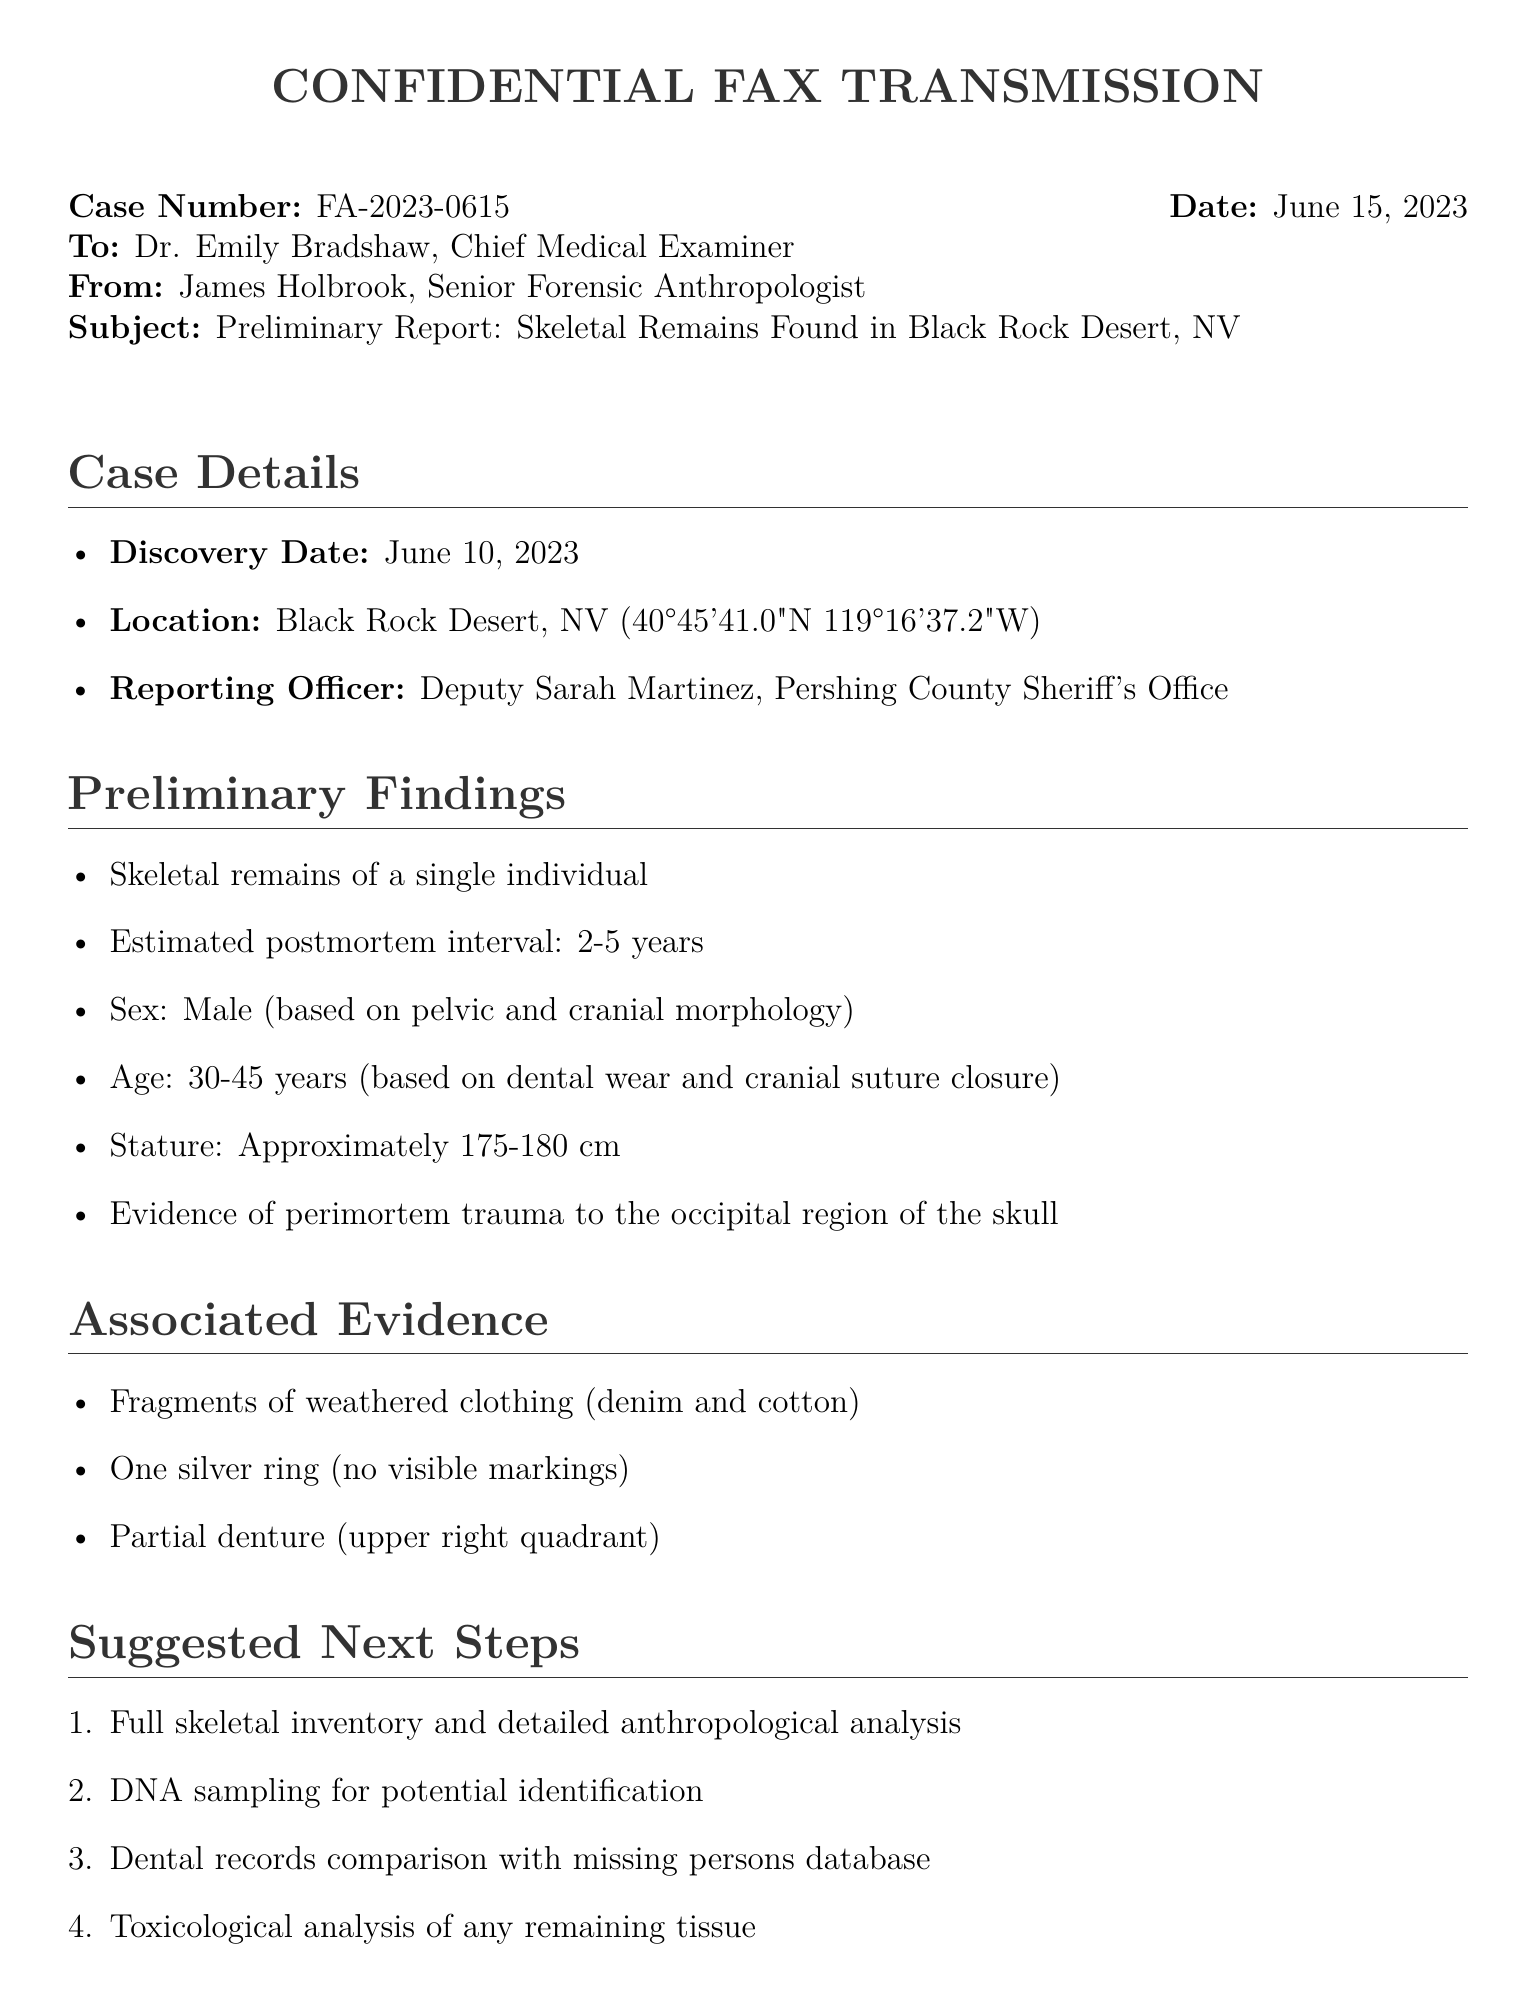What is the case number? The case number is specified at the beginning of the document, which is FA-2023-0615.
Answer: FA-2023-0615 What is the discovery date? The discovery date is listed in the case details section as June 10, 2023.
Answer: June 10, 2023 What is the estimated postmortem interval? The estimated postmortem interval is mentioned in the preliminary findings as 2-5 years.
Answer: 2-5 years What evidence was found with the skeletal remains? The associated evidence listed includes clothing fragments, a silver ring, and a partial denture.
Answer: Clothing fragments, silver ring, partial denture What was the sex of the individual? The sex of the individual is determined based on morphological analysis, noted as male.
Answer: Male What is the suggested next step involving DNA? One of the suggested next steps is to conduct DNA sampling for potential identification.
Answer: DNA sampling for potential identification How many items are listed in the suggested next steps? The number of suggested next steps is found in the enumeration, which totals five items.
Answer: Five Who is the reporting officer? The reporting officer's name is provided in the case details, which is Deputy Sarah Martinez.
Answer: Deputy Sarah Martinez What type of document is this? The format of the document indicates it is a fax transmission, which is a confidential communication.
Answer: Fax transmission 